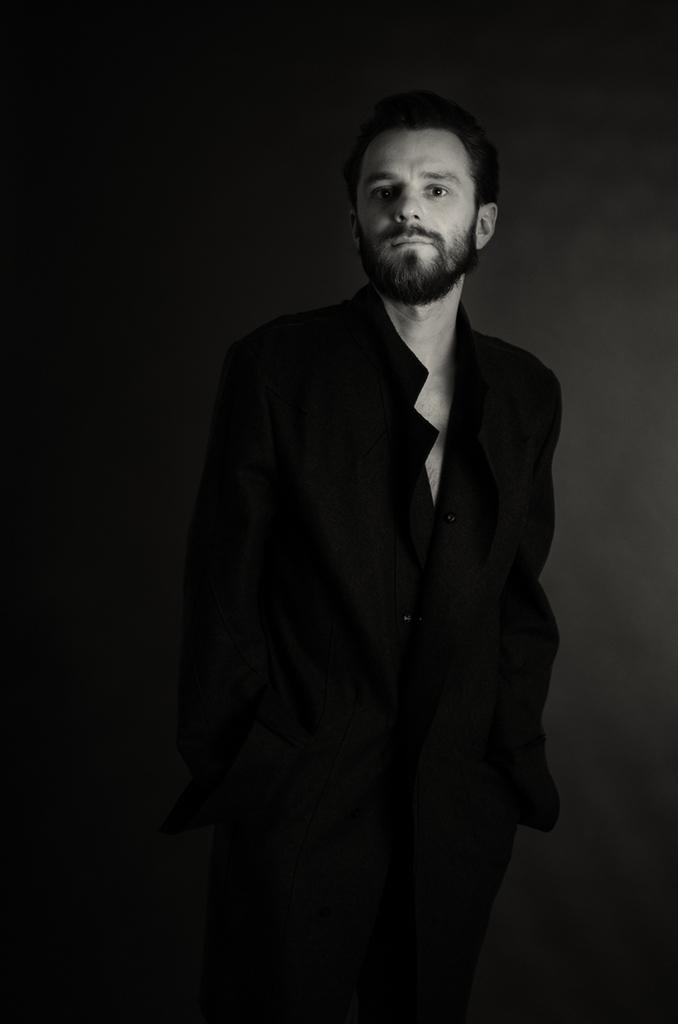What is the color scheme of the image? The image is black and white. Can you describe the person in the image? There is a man in the image. What is the man wearing? The man is wearing a black dress. What type of pancake is the man holding in the image? There is no pancake present in the image; the man is wearing a black dress. Can you read the letter that the man is holding in the image? There is no letter present in the image; the man is wearing a black dress. 